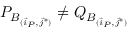<formula> <loc_0><loc_0><loc_500><loc_500>P _ { B _ { ( \vec { i } _ { P } , \vec { j } ^ { * } ) } } \neq Q _ { B _ { ( \vec { i } _ { P } , \vec { j } ^ { * } ) } }</formula> 